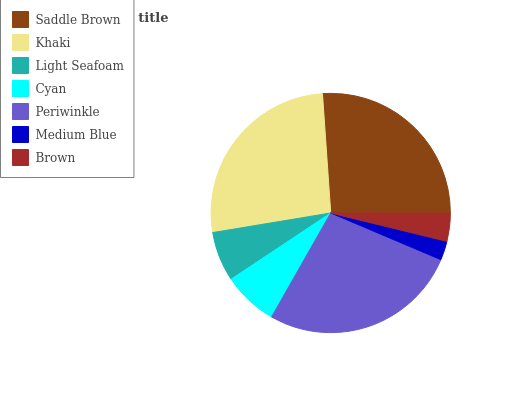Is Medium Blue the minimum?
Answer yes or no. Yes. Is Periwinkle the maximum?
Answer yes or no. Yes. Is Khaki the minimum?
Answer yes or no. No. Is Khaki the maximum?
Answer yes or no. No. Is Khaki greater than Saddle Brown?
Answer yes or no. Yes. Is Saddle Brown less than Khaki?
Answer yes or no. Yes. Is Saddle Brown greater than Khaki?
Answer yes or no. No. Is Khaki less than Saddle Brown?
Answer yes or no. No. Is Cyan the high median?
Answer yes or no. Yes. Is Cyan the low median?
Answer yes or no. Yes. Is Saddle Brown the high median?
Answer yes or no. No. Is Periwinkle the low median?
Answer yes or no. No. 